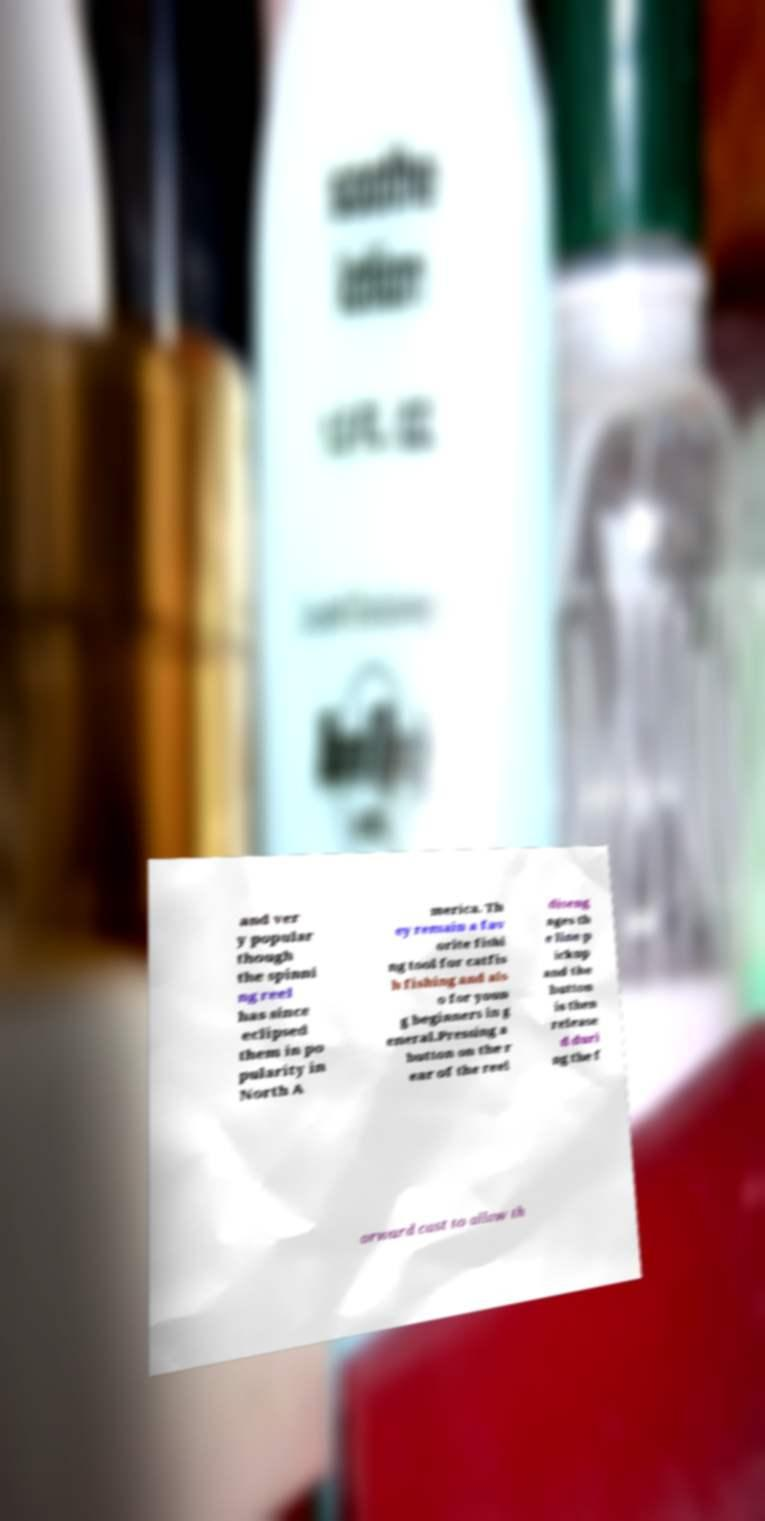Can you read and provide the text displayed in the image?This photo seems to have some interesting text. Can you extract and type it out for me? and ver y popular though the spinni ng reel has since eclipsed them in po pularity in North A merica. Th ey remain a fav orite fishi ng tool for catfis h fishing and als o for youn g beginners in g eneral.Pressing a button on the r ear of the reel diseng ages th e line p ickup and the button is then release d duri ng the f orward cast to allow th 